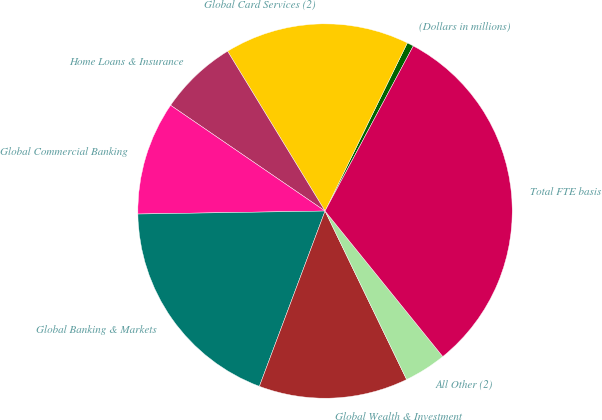<chart> <loc_0><loc_0><loc_500><loc_500><pie_chart><fcel>(Dollars in millions)<fcel>Global Card Services (2)<fcel>Home Loans & Insurance<fcel>Global Commercial Banking<fcel>Global Banking & Markets<fcel>Global Wealth & Investment<fcel>All Other (2)<fcel>Total FTE basis<nl><fcel>0.57%<fcel>15.96%<fcel>6.73%<fcel>9.81%<fcel>19.04%<fcel>12.88%<fcel>3.65%<fcel>31.36%<nl></chart> 